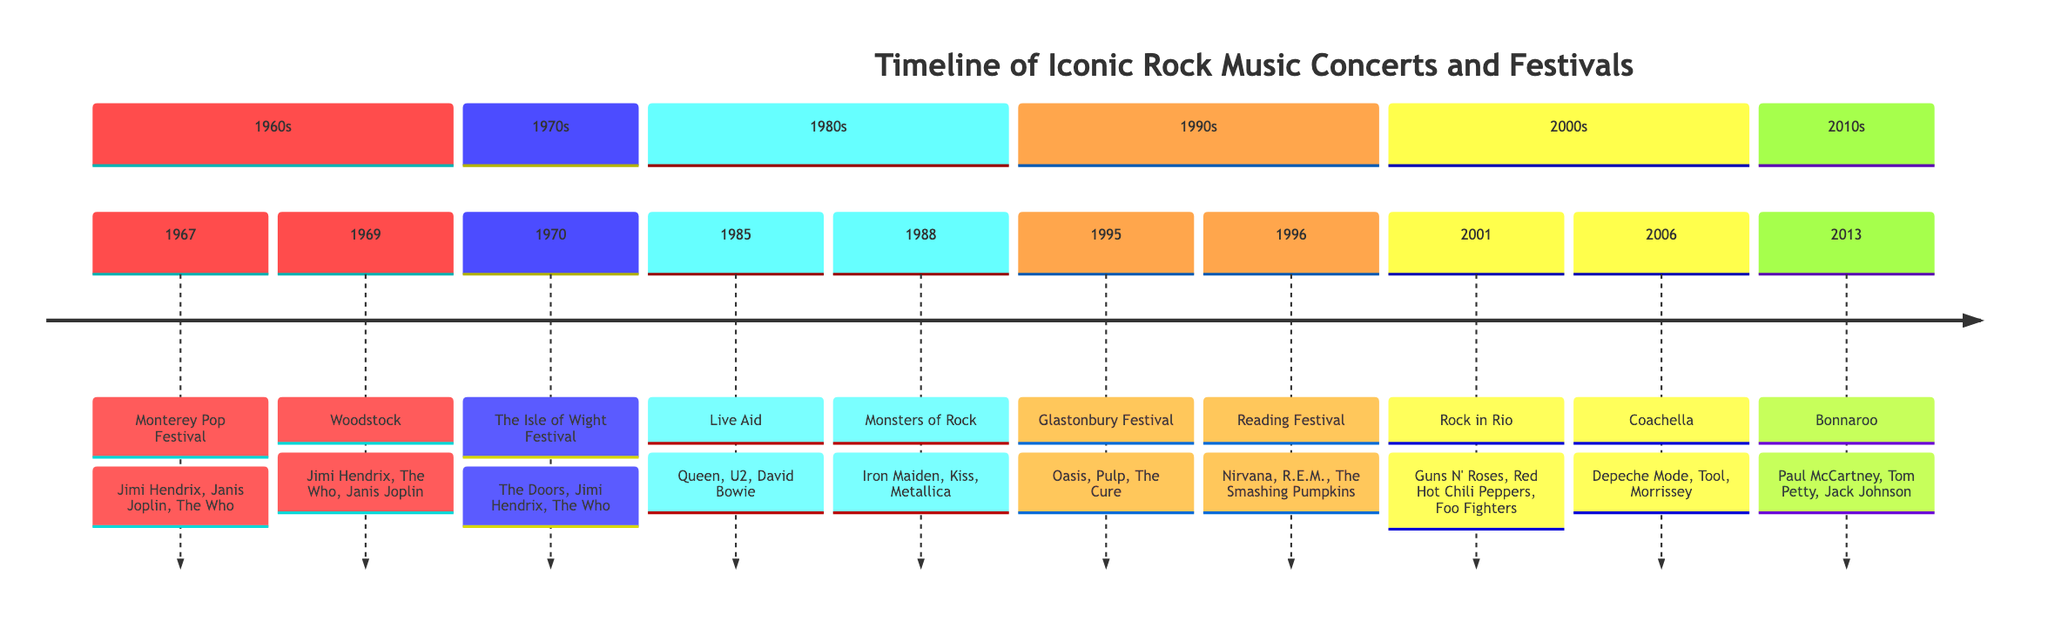What event happened in 1969? From the timeline, in the section of the 1960s, the event listed for 1969 is "Woodstock."
Answer: Woodstock Which festival featured Jimi Hendrix, Janis Joplin, and The Who? In the 1967 entry, the "Monterey Pop Festival" featured those artists. The 1969 entry also shows Jimi Hendrix and The Who performing at Woodstock, but all three performed together at the Monterey Pop Festival.
Answer: Monterey Pop Festival How many festivals are listed in the 1970s section? The 1970s section contains one event, which is "The Isle of Wight Festival." Hence, the count is one.
Answer: 1 Which year did Live Aid take place? Looking at the 1980s section, Live Aid is marked as taking place in 1985.
Answer: 1985 What is the last concert listed in this timeline? The last concert mentioned in the timeline is "Bonnaroo," which occurred in 2013 in the 2010s section.
Answer: Bonnaroo How many acts performed at the Glastonbury Festival? In the 1995 section for the Glastonbury Festival, three artists are noted: Oasis, Pulp, and The Cure. Thus, the total count of acts is three.
Answer: 3 Which festival featured bands like Iron Maiden, Kiss, and Metallica? In the 1988 entry of the timeline, "Monsters of Rock" is listed as featuring those bands.
Answer: Monsters of Rock Which decade saw both The Doors and Jimi Hendrix perform together? In the timeline, both The Doors and Jimi Hendrix are noted to perform at "The Isle of Wight Festival" in 1970, which is in the 1970s decade.
Answer: 1970s What notable artist performed at Coachella in 2006? The timeline lists "Morrissey" as one of the acts at Coachella in 2006.
Answer: Morrissey 